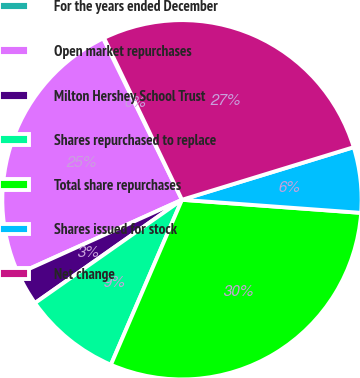Convert chart. <chart><loc_0><loc_0><loc_500><loc_500><pie_chart><fcel>For the years ended December<fcel>Open market repurchases<fcel>Milton Hershey School Trust<fcel>Shares repurchased to replace<fcel>Total share repurchases<fcel>Shares issued for stock<fcel>Net change<nl><fcel>0.09%<fcel>24.52%<fcel>2.99%<fcel>8.78%<fcel>30.31%<fcel>5.89%<fcel>27.41%<nl></chart> 